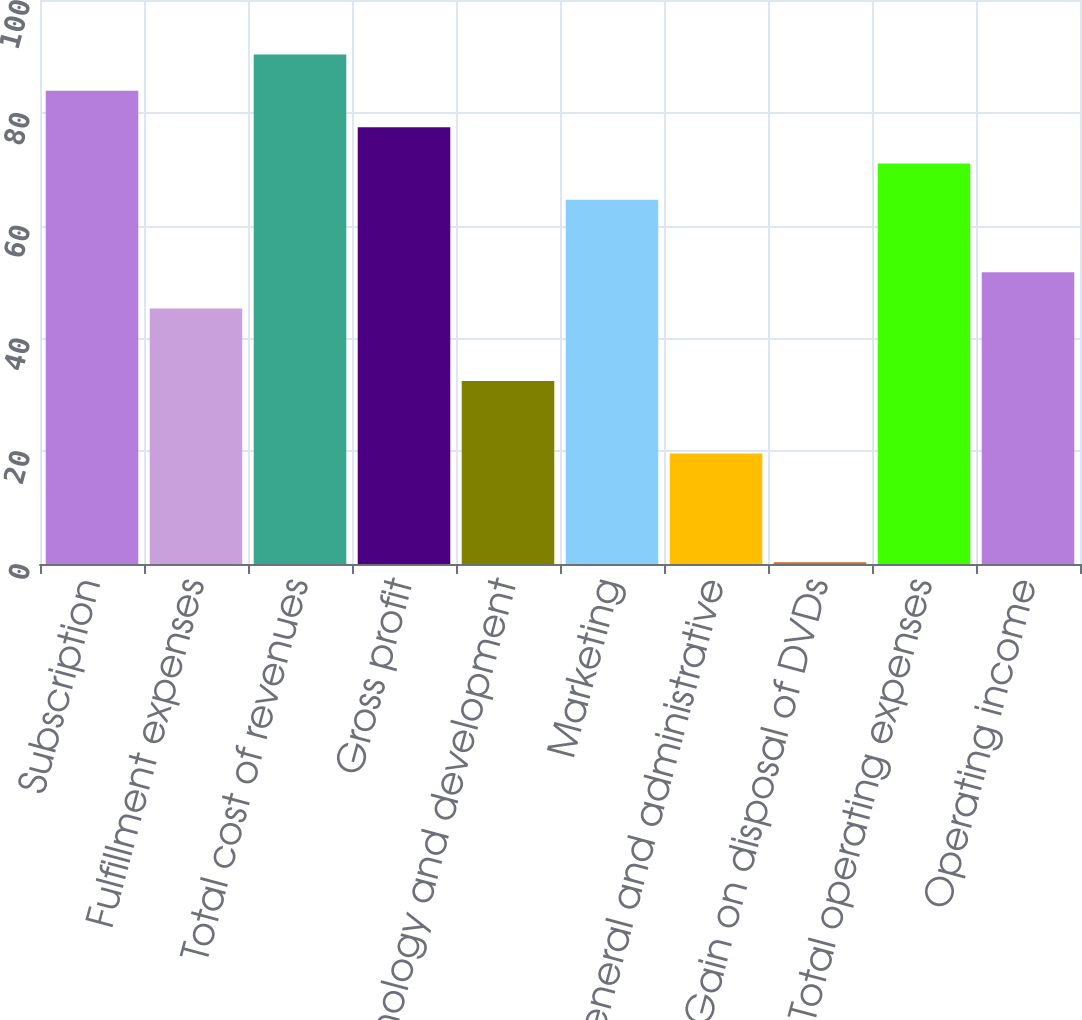Convert chart. <chart><loc_0><loc_0><loc_500><loc_500><bar_chart><fcel>Subscription<fcel>Fulfillment expenses<fcel>Total cost of revenues<fcel>Gross profit<fcel>Technology and development<fcel>Marketing<fcel>General and administrative<fcel>Gain on disposal of DVDs<fcel>Total operating expenses<fcel>Operating income<nl><fcel>83.89<fcel>45.31<fcel>90.32<fcel>77.46<fcel>32.45<fcel>64.6<fcel>19.59<fcel>0.3<fcel>71.03<fcel>51.74<nl></chart> 